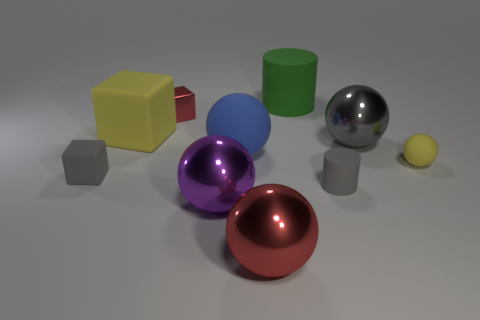Does the small ball have the same color as the large rubber cube?
Your answer should be very brief. Yes. There is a big shiny thing that is the same color as the metallic cube; what is its shape?
Provide a short and direct response. Sphere. Is there a matte cylinder?
Provide a succinct answer. Yes. The green cylinder that is the same material as the blue object is what size?
Provide a short and direct response. Large. What shape is the gray object behind the yellow rubber thing to the right of the red metal thing behind the big red ball?
Your answer should be compact. Sphere. Are there the same number of blue spheres behind the small gray block and gray cubes?
Make the answer very short. Yes. The object that is the same color as the large cube is what size?
Your answer should be compact. Small. Do the small yellow matte thing and the large red shiny object have the same shape?
Provide a short and direct response. Yes. What number of objects are big metallic things that are to the right of the red block or big green cylinders?
Offer a very short reply. 4. Are there an equal number of cylinders in front of the purple sphere and small matte spheres that are to the right of the big green cylinder?
Offer a very short reply. No. 